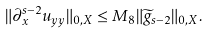Convert formula to latex. <formula><loc_0><loc_0><loc_500><loc_500>\| \partial _ { x } ^ { s - 2 } u _ { y y } \| _ { 0 , X } \leq M _ { 8 } \| \widetilde { g } _ { s - 2 } \| _ { 0 , X } .</formula> 